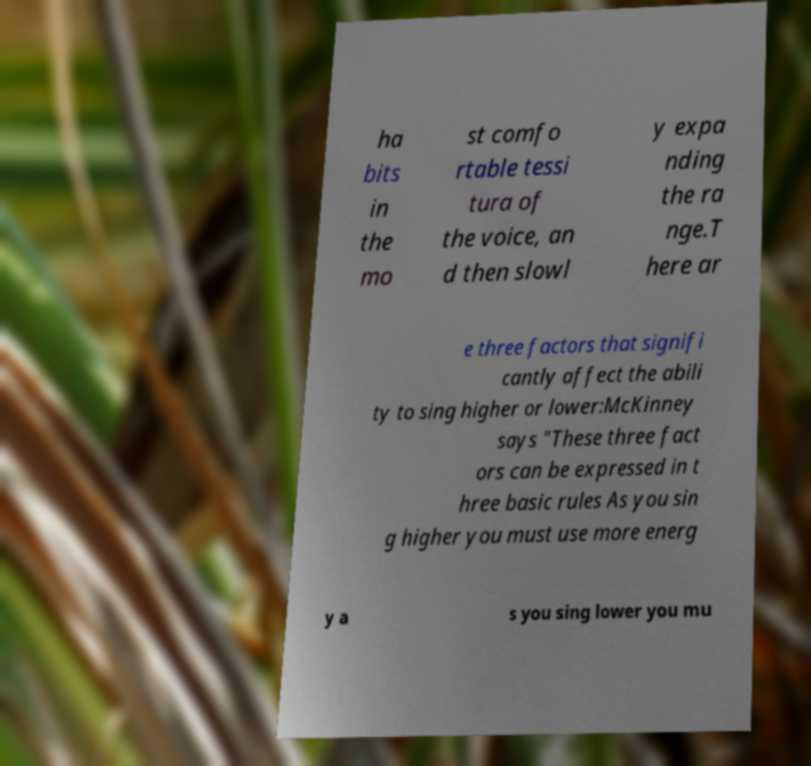What messages or text are displayed in this image? I need them in a readable, typed format. ha bits in the mo st comfo rtable tessi tura of the voice, an d then slowl y expa nding the ra nge.T here ar e three factors that signifi cantly affect the abili ty to sing higher or lower:McKinney says "These three fact ors can be expressed in t hree basic rules As you sin g higher you must use more energ y a s you sing lower you mu 